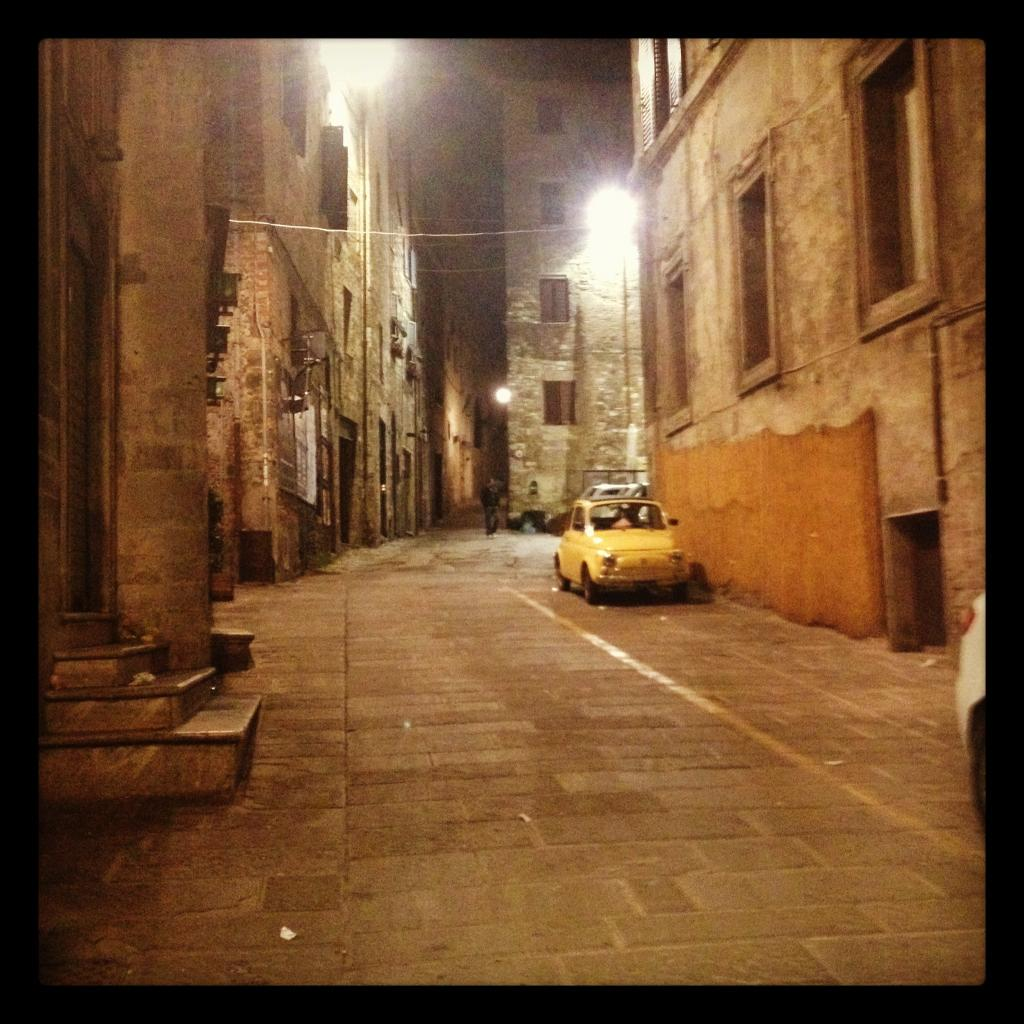What type of structures are present in the image? There are buildings with walls in the image. What features can be seen on the buildings? The buildings have windows. What architectural element is visible in the image? There are steps in the image. What mode of transportation can be seen in the image? There is a car on the road in the image. Are there any people present in the image? Yes, there is a person in the image. What type of lipstick is the crowd wearing in the image? There is no crowd present in the image, and therefore no lipstick can be observed. What source of power is being used by the person in the image? The image does not provide information about the person's source of power, such as electricity or fuel. 